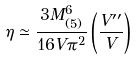Convert formula to latex. <formula><loc_0><loc_0><loc_500><loc_500>\eta \simeq \frac { 3 M _ { ( 5 ) } ^ { 6 } } { 1 6 V \pi ^ { 2 } } \left ( \frac { V ^ { \prime \prime } } { V } \right )</formula> 